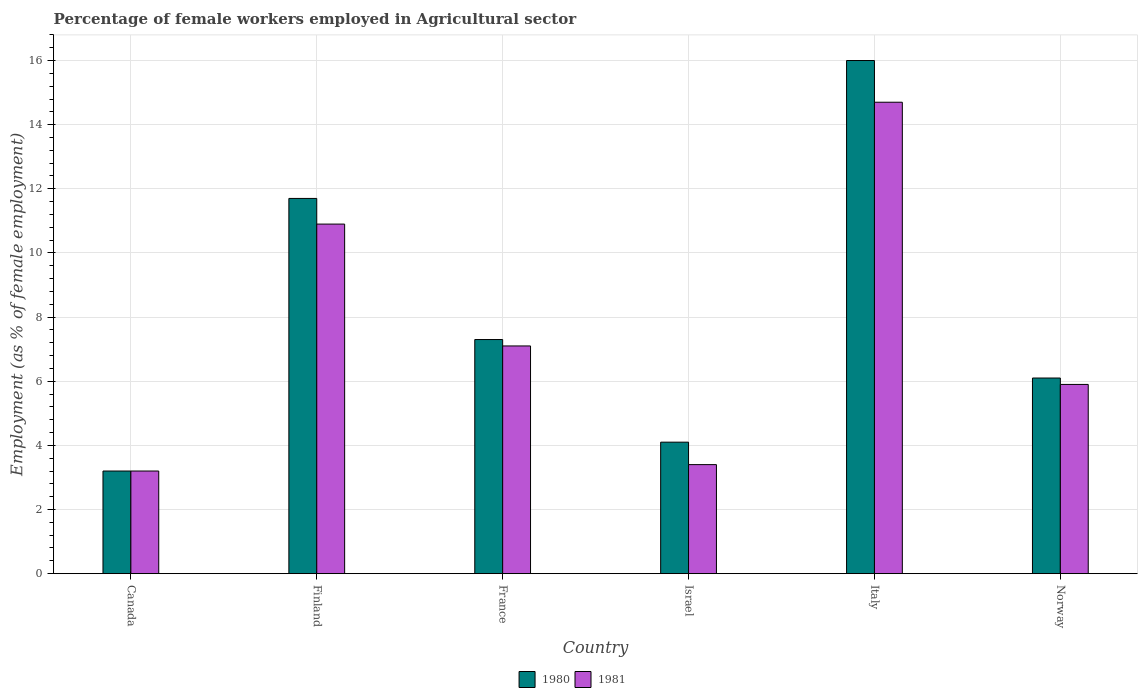How many different coloured bars are there?
Keep it short and to the point. 2. How many groups of bars are there?
Provide a short and direct response. 6. Are the number of bars per tick equal to the number of legend labels?
Provide a short and direct response. Yes. Are the number of bars on each tick of the X-axis equal?
Make the answer very short. Yes. How many bars are there on the 4th tick from the left?
Your response must be concise. 2. In how many cases, is the number of bars for a given country not equal to the number of legend labels?
Keep it short and to the point. 0. What is the percentage of females employed in Agricultural sector in 1980 in Israel?
Keep it short and to the point. 4.1. Across all countries, what is the maximum percentage of females employed in Agricultural sector in 1981?
Ensure brevity in your answer.  14.7. Across all countries, what is the minimum percentage of females employed in Agricultural sector in 1981?
Your answer should be compact. 3.2. In which country was the percentage of females employed in Agricultural sector in 1980 minimum?
Give a very brief answer. Canada. What is the total percentage of females employed in Agricultural sector in 1980 in the graph?
Ensure brevity in your answer.  48.4. What is the difference between the percentage of females employed in Agricultural sector in 1981 in Finland and that in Israel?
Provide a succinct answer. 7.5. What is the difference between the percentage of females employed in Agricultural sector in 1980 in Finland and the percentage of females employed in Agricultural sector in 1981 in Israel?
Offer a very short reply. 8.3. What is the average percentage of females employed in Agricultural sector in 1981 per country?
Ensure brevity in your answer.  7.53. What is the ratio of the percentage of females employed in Agricultural sector in 1980 in Canada to that in Israel?
Keep it short and to the point. 0.78. What is the difference between the highest and the second highest percentage of females employed in Agricultural sector in 1980?
Offer a terse response. 4.3. What is the difference between the highest and the lowest percentage of females employed in Agricultural sector in 1981?
Offer a very short reply. 11.5. Is the sum of the percentage of females employed in Agricultural sector in 1981 in Italy and Norway greater than the maximum percentage of females employed in Agricultural sector in 1980 across all countries?
Give a very brief answer. Yes. What does the 1st bar from the left in Italy represents?
Offer a terse response. 1980. What is the difference between two consecutive major ticks on the Y-axis?
Give a very brief answer. 2. Are the values on the major ticks of Y-axis written in scientific E-notation?
Make the answer very short. No. Does the graph contain any zero values?
Offer a very short reply. No. Does the graph contain grids?
Provide a short and direct response. Yes. Where does the legend appear in the graph?
Ensure brevity in your answer.  Bottom center. How many legend labels are there?
Ensure brevity in your answer.  2. What is the title of the graph?
Ensure brevity in your answer.  Percentage of female workers employed in Agricultural sector. Does "1975" appear as one of the legend labels in the graph?
Keep it short and to the point. No. What is the label or title of the Y-axis?
Your answer should be compact. Employment (as % of female employment). What is the Employment (as % of female employment) in 1980 in Canada?
Give a very brief answer. 3.2. What is the Employment (as % of female employment) in 1981 in Canada?
Offer a very short reply. 3.2. What is the Employment (as % of female employment) in 1980 in Finland?
Your response must be concise. 11.7. What is the Employment (as % of female employment) of 1981 in Finland?
Ensure brevity in your answer.  10.9. What is the Employment (as % of female employment) of 1980 in France?
Give a very brief answer. 7.3. What is the Employment (as % of female employment) of 1981 in France?
Keep it short and to the point. 7.1. What is the Employment (as % of female employment) in 1980 in Israel?
Ensure brevity in your answer.  4.1. What is the Employment (as % of female employment) of 1981 in Israel?
Make the answer very short. 3.4. What is the Employment (as % of female employment) of 1980 in Italy?
Make the answer very short. 16. What is the Employment (as % of female employment) in 1981 in Italy?
Your response must be concise. 14.7. What is the Employment (as % of female employment) in 1980 in Norway?
Your answer should be compact. 6.1. What is the Employment (as % of female employment) in 1981 in Norway?
Provide a short and direct response. 5.9. Across all countries, what is the maximum Employment (as % of female employment) in 1981?
Ensure brevity in your answer.  14.7. Across all countries, what is the minimum Employment (as % of female employment) in 1980?
Offer a very short reply. 3.2. Across all countries, what is the minimum Employment (as % of female employment) of 1981?
Provide a succinct answer. 3.2. What is the total Employment (as % of female employment) of 1980 in the graph?
Your answer should be very brief. 48.4. What is the total Employment (as % of female employment) in 1981 in the graph?
Give a very brief answer. 45.2. What is the difference between the Employment (as % of female employment) in 1980 in Canada and that in Finland?
Your response must be concise. -8.5. What is the difference between the Employment (as % of female employment) of 1981 in Canada and that in Finland?
Keep it short and to the point. -7.7. What is the difference between the Employment (as % of female employment) of 1980 in Canada and that in France?
Your answer should be very brief. -4.1. What is the difference between the Employment (as % of female employment) of 1981 in Canada and that in France?
Your answer should be compact. -3.9. What is the difference between the Employment (as % of female employment) of 1980 in Canada and that in Israel?
Offer a very short reply. -0.9. What is the difference between the Employment (as % of female employment) of 1981 in Canada and that in Israel?
Offer a very short reply. -0.2. What is the difference between the Employment (as % of female employment) in 1980 in Canada and that in Italy?
Make the answer very short. -12.8. What is the difference between the Employment (as % of female employment) in 1980 in Finland and that in Israel?
Offer a terse response. 7.6. What is the difference between the Employment (as % of female employment) in 1981 in Finland and that in Israel?
Give a very brief answer. 7.5. What is the difference between the Employment (as % of female employment) of 1981 in Finland and that in Italy?
Your answer should be compact. -3.8. What is the difference between the Employment (as % of female employment) of 1981 in Finland and that in Norway?
Your answer should be compact. 5. What is the difference between the Employment (as % of female employment) in 1981 in France and that in Israel?
Provide a succinct answer. 3.7. What is the difference between the Employment (as % of female employment) of 1981 in France and that in Italy?
Make the answer very short. -7.6. What is the difference between the Employment (as % of female employment) of 1981 in France and that in Norway?
Your response must be concise. 1.2. What is the difference between the Employment (as % of female employment) of 1980 in Israel and that in Italy?
Ensure brevity in your answer.  -11.9. What is the difference between the Employment (as % of female employment) of 1981 in Israel and that in Italy?
Ensure brevity in your answer.  -11.3. What is the difference between the Employment (as % of female employment) of 1981 in Israel and that in Norway?
Your response must be concise. -2.5. What is the difference between the Employment (as % of female employment) in 1980 in Canada and the Employment (as % of female employment) in 1981 in France?
Your answer should be compact. -3.9. What is the difference between the Employment (as % of female employment) of 1980 in Finland and the Employment (as % of female employment) of 1981 in Israel?
Provide a short and direct response. 8.3. What is the difference between the Employment (as % of female employment) of 1980 in Finland and the Employment (as % of female employment) of 1981 in Italy?
Your response must be concise. -3. What is the difference between the Employment (as % of female employment) in 1980 in Israel and the Employment (as % of female employment) in 1981 in Italy?
Your response must be concise. -10.6. What is the difference between the Employment (as % of female employment) in 1980 in Israel and the Employment (as % of female employment) in 1981 in Norway?
Make the answer very short. -1.8. What is the difference between the Employment (as % of female employment) in 1980 in Italy and the Employment (as % of female employment) in 1981 in Norway?
Your answer should be compact. 10.1. What is the average Employment (as % of female employment) of 1980 per country?
Your answer should be very brief. 8.07. What is the average Employment (as % of female employment) of 1981 per country?
Provide a succinct answer. 7.53. What is the difference between the Employment (as % of female employment) of 1980 and Employment (as % of female employment) of 1981 in Finland?
Provide a short and direct response. 0.8. What is the difference between the Employment (as % of female employment) of 1980 and Employment (as % of female employment) of 1981 in France?
Your answer should be compact. 0.2. What is the difference between the Employment (as % of female employment) of 1980 and Employment (as % of female employment) of 1981 in Israel?
Keep it short and to the point. 0.7. What is the ratio of the Employment (as % of female employment) of 1980 in Canada to that in Finland?
Keep it short and to the point. 0.27. What is the ratio of the Employment (as % of female employment) of 1981 in Canada to that in Finland?
Offer a very short reply. 0.29. What is the ratio of the Employment (as % of female employment) of 1980 in Canada to that in France?
Provide a succinct answer. 0.44. What is the ratio of the Employment (as % of female employment) in 1981 in Canada to that in France?
Provide a succinct answer. 0.45. What is the ratio of the Employment (as % of female employment) in 1980 in Canada to that in Israel?
Your answer should be very brief. 0.78. What is the ratio of the Employment (as % of female employment) of 1981 in Canada to that in Israel?
Make the answer very short. 0.94. What is the ratio of the Employment (as % of female employment) of 1981 in Canada to that in Italy?
Offer a very short reply. 0.22. What is the ratio of the Employment (as % of female employment) in 1980 in Canada to that in Norway?
Offer a very short reply. 0.52. What is the ratio of the Employment (as % of female employment) in 1981 in Canada to that in Norway?
Provide a short and direct response. 0.54. What is the ratio of the Employment (as % of female employment) in 1980 in Finland to that in France?
Keep it short and to the point. 1.6. What is the ratio of the Employment (as % of female employment) of 1981 in Finland to that in France?
Keep it short and to the point. 1.54. What is the ratio of the Employment (as % of female employment) in 1980 in Finland to that in Israel?
Offer a very short reply. 2.85. What is the ratio of the Employment (as % of female employment) of 1981 in Finland to that in Israel?
Your response must be concise. 3.21. What is the ratio of the Employment (as % of female employment) in 1980 in Finland to that in Italy?
Your answer should be compact. 0.73. What is the ratio of the Employment (as % of female employment) of 1981 in Finland to that in Italy?
Ensure brevity in your answer.  0.74. What is the ratio of the Employment (as % of female employment) of 1980 in Finland to that in Norway?
Give a very brief answer. 1.92. What is the ratio of the Employment (as % of female employment) of 1981 in Finland to that in Norway?
Make the answer very short. 1.85. What is the ratio of the Employment (as % of female employment) in 1980 in France to that in Israel?
Keep it short and to the point. 1.78. What is the ratio of the Employment (as % of female employment) of 1981 in France to that in Israel?
Your answer should be compact. 2.09. What is the ratio of the Employment (as % of female employment) in 1980 in France to that in Italy?
Keep it short and to the point. 0.46. What is the ratio of the Employment (as % of female employment) in 1981 in France to that in Italy?
Ensure brevity in your answer.  0.48. What is the ratio of the Employment (as % of female employment) of 1980 in France to that in Norway?
Provide a succinct answer. 1.2. What is the ratio of the Employment (as % of female employment) in 1981 in France to that in Norway?
Your response must be concise. 1.2. What is the ratio of the Employment (as % of female employment) of 1980 in Israel to that in Italy?
Keep it short and to the point. 0.26. What is the ratio of the Employment (as % of female employment) in 1981 in Israel to that in Italy?
Offer a terse response. 0.23. What is the ratio of the Employment (as % of female employment) of 1980 in Israel to that in Norway?
Give a very brief answer. 0.67. What is the ratio of the Employment (as % of female employment) in 1981 in Israel to that in Norway?
Make the answer very short. 0.58. What is the ratio of the Employment (as % of female employment) in 1980 in Italy to that in Norway?
Provide a succinct answer. 2.62. What is the ratio of the Employment (as % of female employment) in 1981 in Italy to that in Norway?
Your response must be concise. 2.49. What is the difference between the highest and the lowest Employment (as % of female employment) of 1980?
Give a very brief answer. 12.8. 